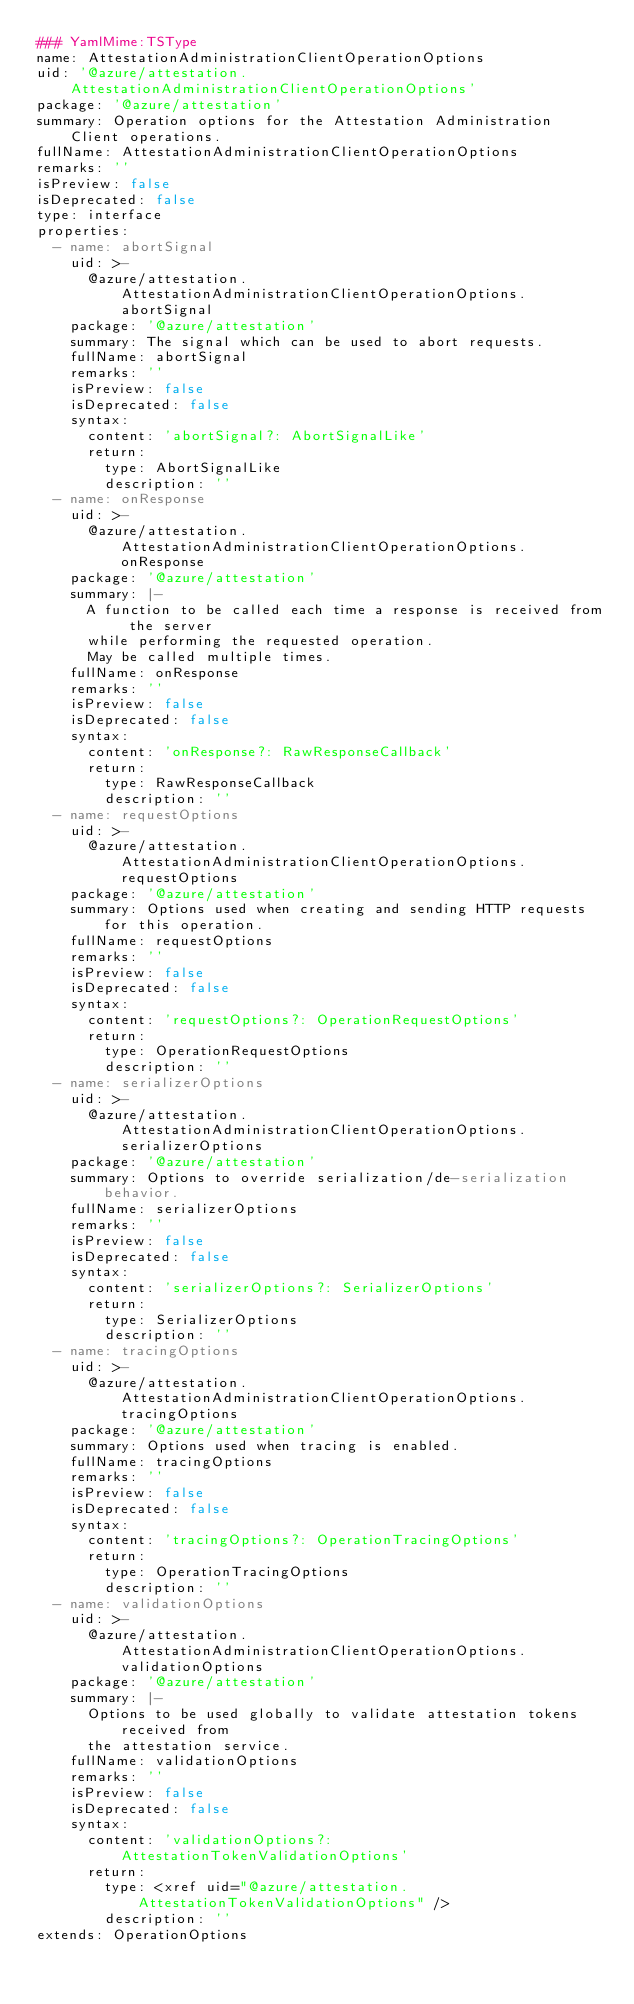Convert code to text. <code><loc_0><loc_0><loc_500><loc_500><_YAML_>### YamlMime:TSType
name: AttestationAdministrationClientOperationOptions
uid: '@azure/attestation.AttestationAdministrationClientOperationOptions'
package: '@azure/attestation'
summary: Operation options for the Attestation Administration Client operations.
fullName: AttestationAdministrationClientOperationOptions
remarks: ''
isPreview: false
isDeprecated: false
type: interface
properties:
  - name: abortSignal
    uid: >-
      @azure/attestation.AttestationAdministrationClientOperationOptions.abortSignal
    package: '@azure/attestation'
    summary: The signal which can be used to abort requests.
    fullName: abortSignal
    remarks: ''
    isPreview: false
    isDeprecated: false
    syntax:
      content: 'abortSignal?: AbortSignalLike'
      return:
        type: AbortSignalLike
        description: ''
  - name: onResponse
    uid: >-
      @azure/attestation.AttestationAdministrationClientOperationOptions.onResponse
    package: '@azure/attestation'
    summary: |-
      A function to be called each time a response is received from the server
      while performing the requested operation.
      May be called multiple times.
    fullName: onResponse
    remarks: ''
    isPreview: false
    isDeprecated: false
    syntax:
      content: 'onResponse?: RawResponseCallback'
      return:
        type: RawResponseCallback
        description: ''
  - name: requestOptions
    uid: >-
      @azure/attestation.AttestationAdministrationClientOperationOptions.requestOptions
    package: '@azure/attestation'
    summary: Options used when creating and sending HTTP requests for this operation.
    fullName: requestOptions
    remarks: ''
    isPreview: false
    isDeprecated: false
    syntax:
      content: 'requestOptions?: OperationRequestOptions'
      return:
        type: OperationRequestOptions
        description: ''
  - name: serializerOptions
    uid: >-
      @azure/attestation.AttestationAdministrationClientOperationOptions.serializerOptions
    package: '@azure/attestation'
    summary: Options to override serialization/de-serialization behavior.
    fullName: serializerOptions
    remarks: ''
    isPreview: false
    isDeprecated: false
    syntax:
      content: 'serializerOptions?: SerializerOptions'
      return:
        type: SerializerOptions
        description: ''
  - name: tracingOptions
    uid: >-
      @azure/attestation.AttestationAdministrationClientOperationOptions.tracingOptions
    package: '@azure/attestation'
    summary: Options used when tracing is enabled.
    fullName: tracingOptions
    remarks: ''
    isPreview: false
    isDeprecated: false
    syntax:
      content: 'tracingOptions?: OperationTracingOptions'
      return:
        type: OperationTracingOptions
        description: ''
  - name: validationOptions
    uid: >-
      @azure/attestation.AttestationAdministrationClientOperationOptions.validationOptions
    package: '@azure/attestation'
    summary: |-
      Options to be used globally to validate attestation tokens received from
      the attestation service.
    fullName: validationOptions
    remarks: ''
    isPreview: false
    isDeprecated: false
    syntax:
      content: 'validationOptions?: AttestationTokenValidationOptions'
      return:
        type: <xref uid="@azure/attestation.AttestationTokenValidationOptions" />
        description: ''
extends: OperationOptions
</code> 